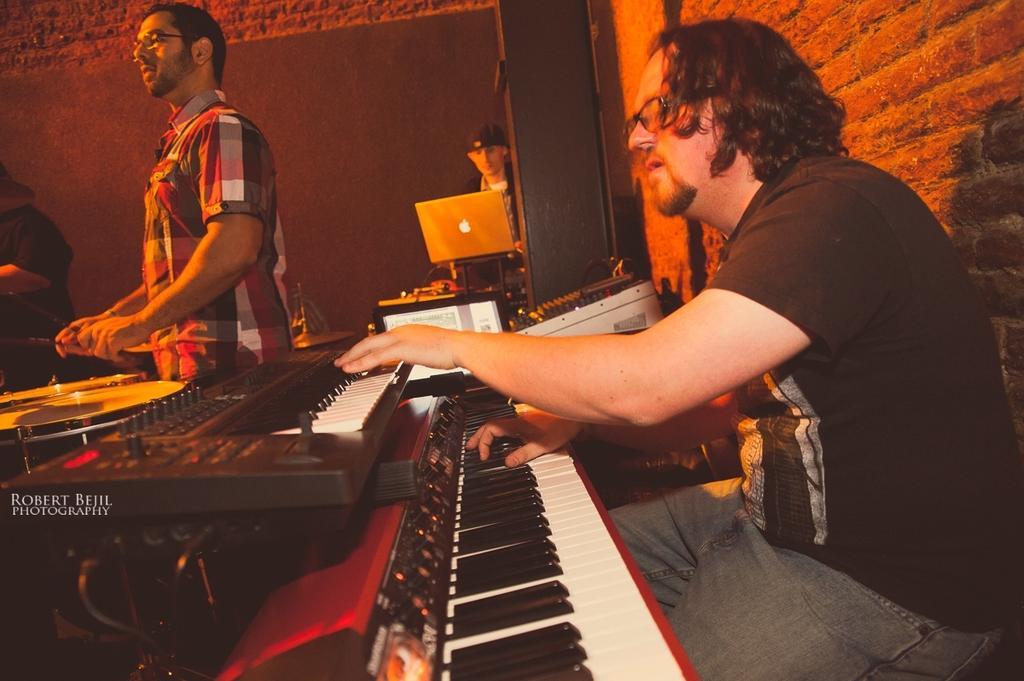Please provide a concise description of this image. There is a man sitting and playing a piano with one hand and with other hand he is operating the amplifier. There is another man who is standing and playing the drums. In the background there is a wall and a man is sitting and using the laptop. The man who is standing has a spectacles. 